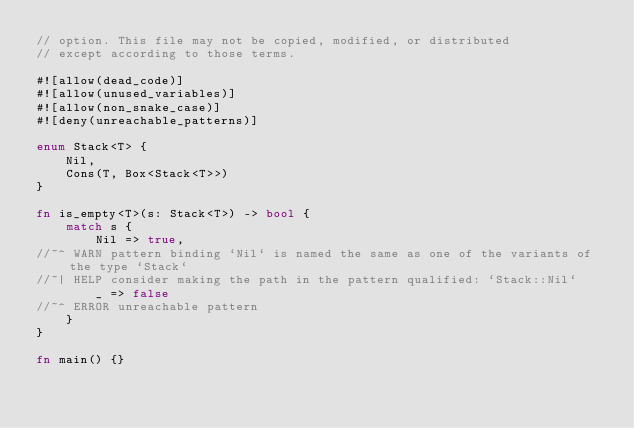<code> <loc_0><loc_0><loc_500><loc_500><_Rust_>// option. This file may not be copied, modified, or distributed
// except according to those terms.

#![allow(dead_code)]
#![allow(unused_variables)]
#![allow(non_snake_case)]
#![deny(unreachable_patterns)]

enum Stack<T> {
    Nil,
    Cons(T, Box<Stack<T>>)
}

fn is_empty<T>(s: Stack<T>) -> bool {
    match s {
        Nil => true,
//~^ WARN pattern binding `Nil` is named the same as one of the variants of the type `Stack`
//~| HELP consider making the path in the pattern qualified: `Stack::Nil`
        _ => false
//~^ ERROR unreachable pattern
    }
}

fn main() {}
</code> 